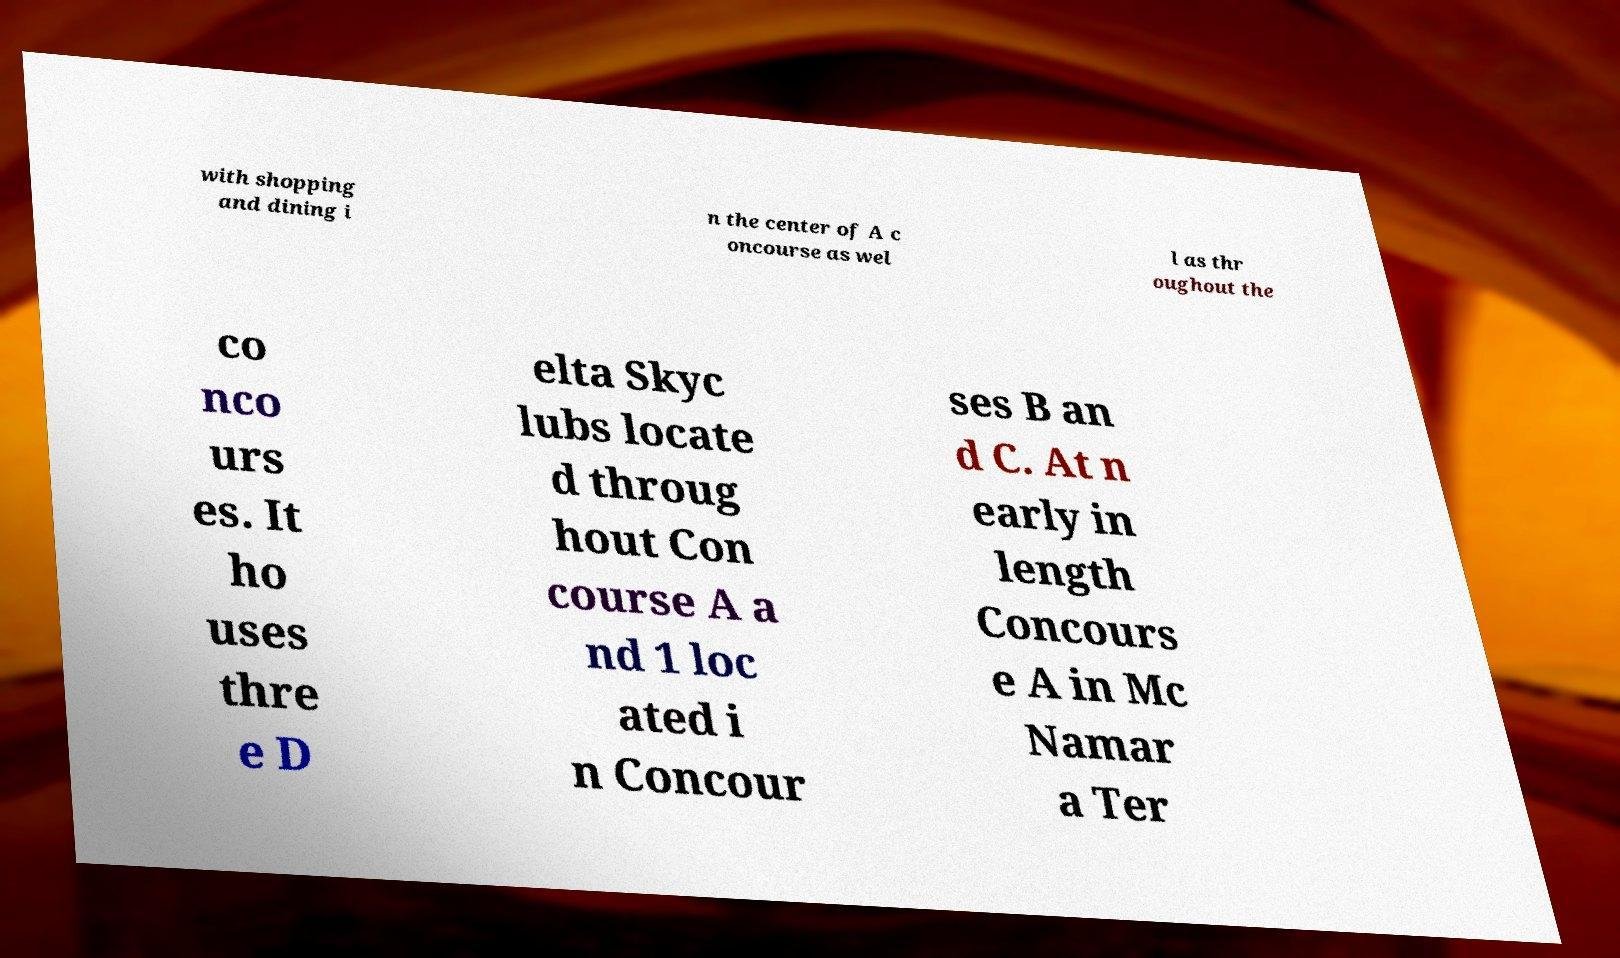Please read and relay the text visible in this image. What does it say? with shopping and dining i n the center of A c oncourse as wel l as thr oughout the co nco urs es. It ho uses thre e D elta Skyc lubs locate d throug hout Con course A a nd 1 loc ated i n Concour ses B an d C. At n early in length Concours e A in Mc Namar a Ter 